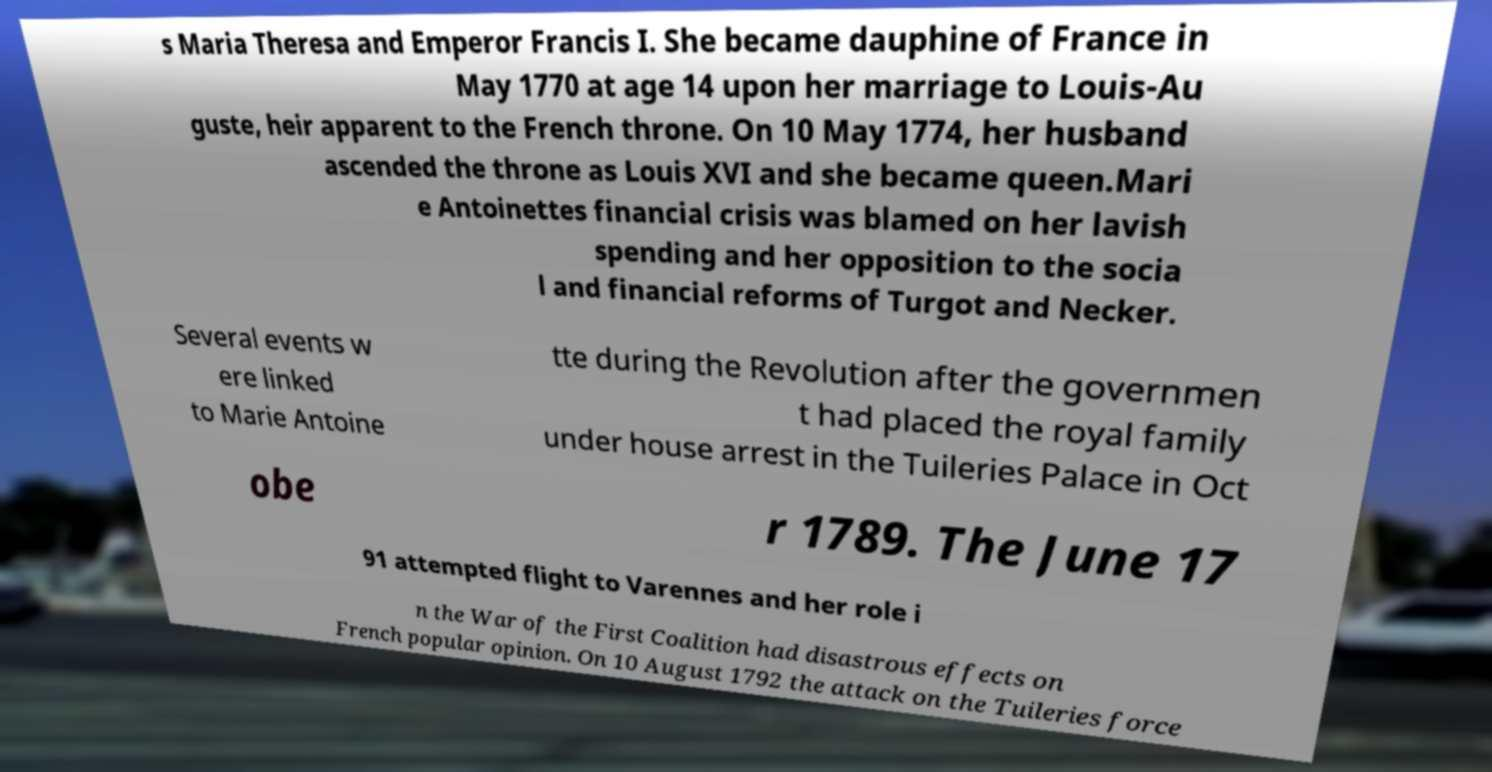Can you accurately transcribe the text from the provided image for me? s Maria Theresa and Emperor Francis I. She became dauphine of France in May 1770 at age 14 upon her marriage to Louis-Au guste, heir apparent to the French throne. On 10 May 1774, her husband ascended the throne as Louis XVI and she became queen.Mari e Antoinettes financial crisis was blamed on her lavish spending and her opposition to the socia l and financial reforms of Turgot and Necker. Several events w ere linked to Marie Antoine tte during the Revolution after the governmen t had placed the royal family under house arrest in the Tuileries Palace in Oct obe r 1789. The June 17 91 attempted flight to Varennes and her role i n the War of the First Coalition had disastrous effects on French popular opinion. On 10 August 1792 the attack on the Tuileries force 